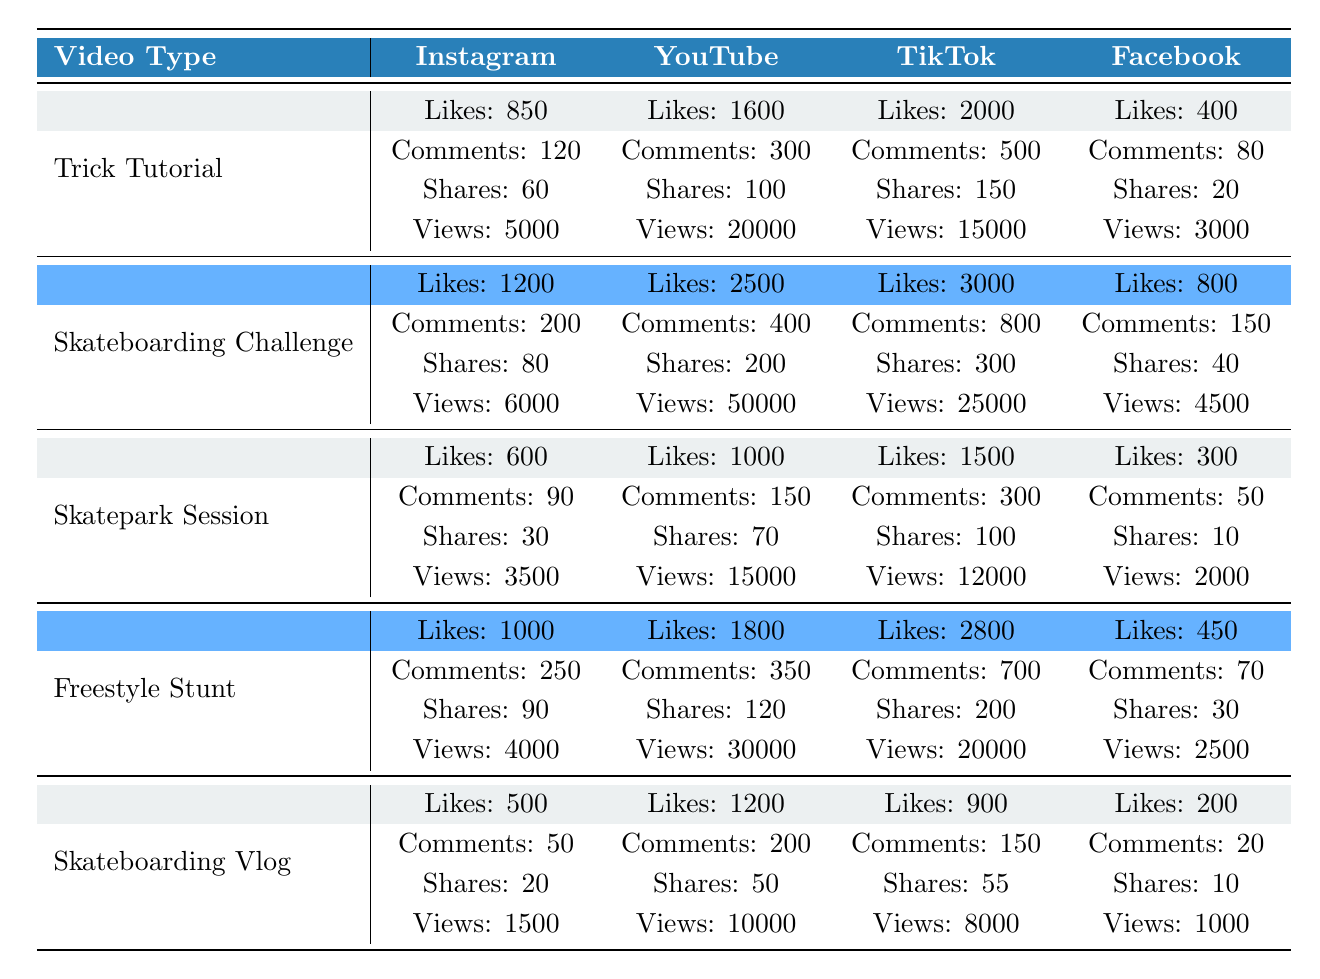What video type received the highest likes on TikTok? According to the table, the Skateboarding Challenge received the highest likes on TikTok, which is 3000.
Answer: Skateboarding Challenge Which platform had the most views for the Freestyle Stunt video? For the Freestyle Stunt video, YouTube had the most views, totaling 30000 views.
Answer: YouTube Is the number of shares for Trick Tutorial on Instagram greater than the number of shares for Skatepark Session on Facebook? The Trick Tutorial on Instagram has 60 shares, while the Skatepark Session on Facebook has only 10 shares. Therefore, the Trick Tutorial has more shares.
Answer: Yes What is the total number of likes for the Skateboarding Vlog across all platforms? The likes for Skateboarding Vlog across platforms are as follows: Instagram has 500, YouTube has 1200, TikTok has 900, and Facebook has 200. Summing these gives 500 + 1200 + 900 + 200 = 2900.
Answer: 2900 Which video type has the most comments on YouTube? The Skateboarding Challenge has the most comments on YouTube, with a total of 400 comments.
Answer: Skateboarding Challenge What is the average number of views for all video types on Instagram? For Instagram, the views are as follows: Trick Tutorial has 5000, Skateboarding Challenge has 6000, Skatepark Session has 3500, Freestyle Stunt has 4000, and Skateboarding Vlog has 1500. Summing these gives 5000 + 6000 + 3500 + 4000 + 1500 = 20500. Dividing by 5 gives an average of 4100.
Answer: 4100 Is the total number of shares across all platforms greater than 1000 for Skateboarding Challenge? The total shares for Skateboarding Challenge are as follows: Instagram has 80, YouTube has 200, TikTok has 300, and Facebook has 40. Summing these: 80 + 200 + 300 + 40 = 620, which is not greater than 1000.
Answer: No 